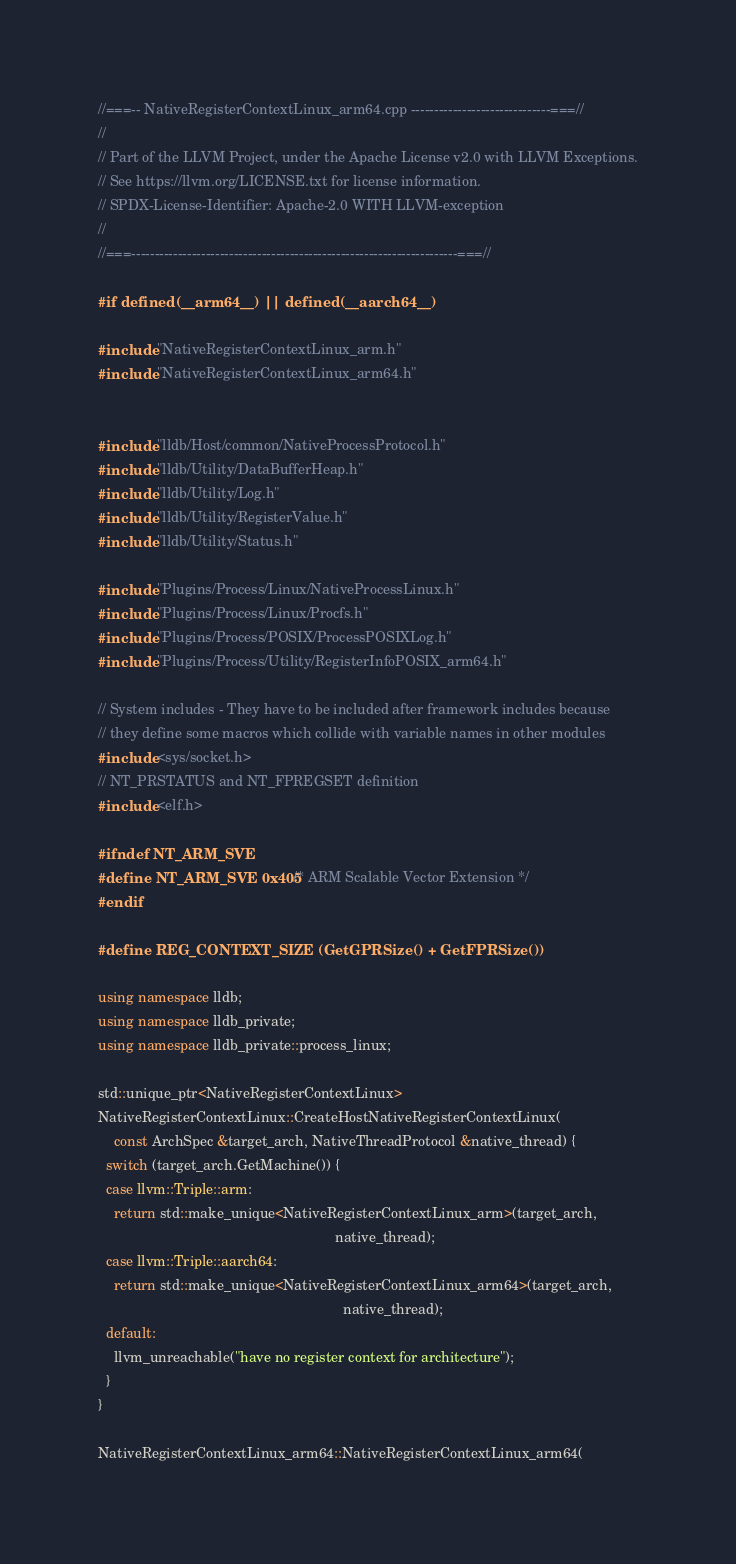Convert code to text. <code><loc_0><loc_0><loc_500><loc_500><_C++_>//===-- NativeRegisterContextLinux_arm64.cpp ------------------------------===//
//
// Part of the LLVM Project, under the Apache License v2.0 with LLVM Exceptions.
// See https://llvm.org/LICENSE.txt for license information.
// SPDX-License-Identifier: Apache-2.0 WITH LLVM-exception
//
//===----------------------------------------------------------------------===//

#if defined(__arm64__) || defined(__aarch64__)

#include "NativeRegisterContextLinux_arm.h"
#include "NativeRegisterContextLinux_arm64.h"


#include "lldb/Host/common/NativeProcessProtocol.h"
#include "lldb/Utility/DataBufferHeap.h"
#include "lldb/Utility/Log.h"
#include "lldb/Utility/RegisterValue.h"
#include "lldb/Utility/Status.h"

#include "Plugins/Process/Linux/NativeProcessLinux.h"
#include "Plugins/Process/Linux/Procfs.h"
#include "Plugins/Process/POSIX/ProcessPOSIXLog.h"
#include "Plugins/Process/Utility/RegisterInfoPOSIX_arm64.h"

// System includes - They have to be included after framework includes because
// they define some macros which collide with variable names in other modules
#include <sys/socket.h>
// NT_PRSTATUS and NT_FPREGSET definition
#include <elf.h>

#ifndef NT_ARM_SVE
#define NT_ARM_SVE 0x405 /* ARM Scalable Vector Extension */
#endif

#define REG_CONTEXT_SIZE (GetGPRSize() + GetFPRSize())

using namespace lldb;
using namespace lldb_private;
using namespace lldb_private::process_linux;

std::unique_ptr<NativeRegisterContextLinux>
NativeRegisterContextLinux::CreateHostNativeRegisterContextLinux(
    const ArchSpec &target_arch, NativeThreadProtocol &native_thread) {
  switch (target_arch.GetMachine()) {
  case llvm::Triple::arm:
    return std::make_unique<NativeRegisterContextLinux_arm>(target_arch,
                                                             native_thread);
  case llvm::Triple::aarch64:
    return std::make_unique<NativeRegisterContextLinux_arm64>(target_arch,
                                                               native_thread);
  default:
    llvm_unreachable("have no register context for architecture");
  }
}

NativeRegisterContextLinux_arm64::NativeRegisterContextLinux_arm64(</code> 